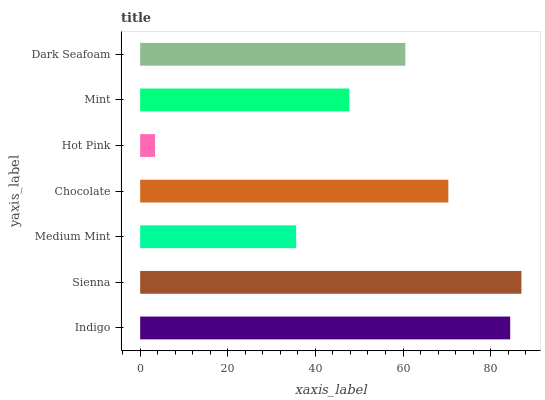Is Hot Pink the minimum?
Answer yes or no. Yes. Is Sienna the maximum?
Answer yes or no. Yes. Is Medium Mint the minimum?
Answer yes or no. No. Is Medium Mint the maximum?
Answer yes or no. No. Is Sienna greater than Medium Mint?
Answer yes or no. Yes. Is Medium Mint less than Sienna?
Answer yes or no. Yes. Is Medium Mint greater than Sienna?
Answer yes or no. No. Is Sienna less than Medium Mint?
Answer yes or no. No. Is Dark Seafoam the high median?
Answer yes or no. Yes. Is Dark Seafoam the low median?
Answer yes or no. Yes. Is Hot Pink the high median?
Answer yes or no. No. Is Indigo the low median?
Answer yes or no. No. 